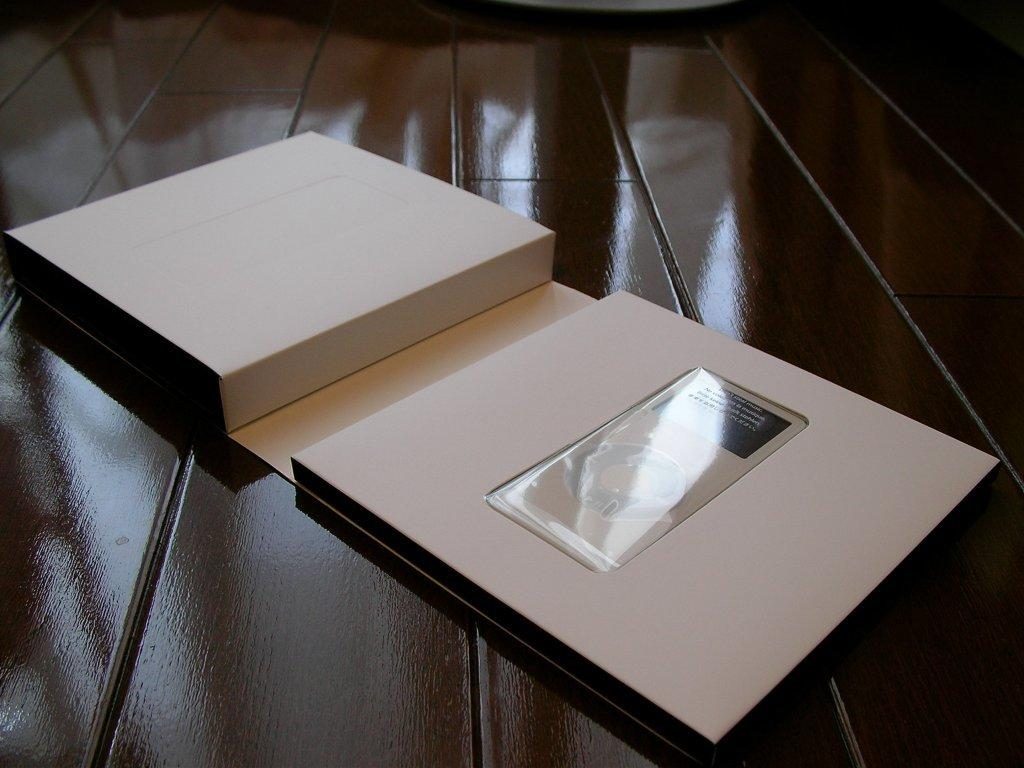What piece of furniture is present in the image? There is a table in the image. What object is placed on the table? There is a box on the table. Is there anything on top of the box? Yes, there is an item placed on the box. What type of oatmeal is being prepared on the table in the image? There is no oatmeal or any indication of food preparation in the image. 